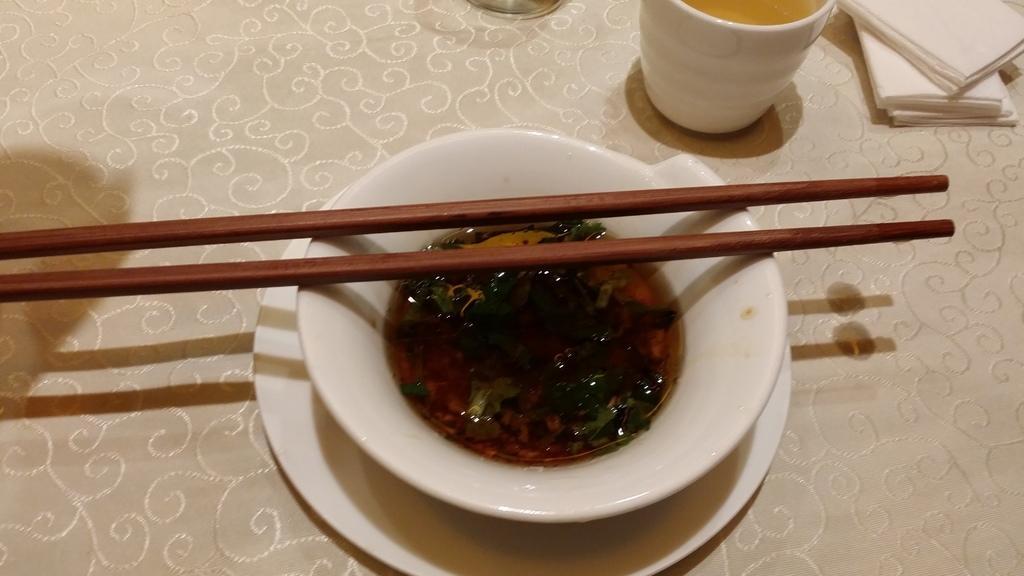Describe this image in one or two sentences. A soul is filled in a bowl. The bowl is kept on a table. There are pair of chopsticks on the bowl. There is a glass beside the bowl. 